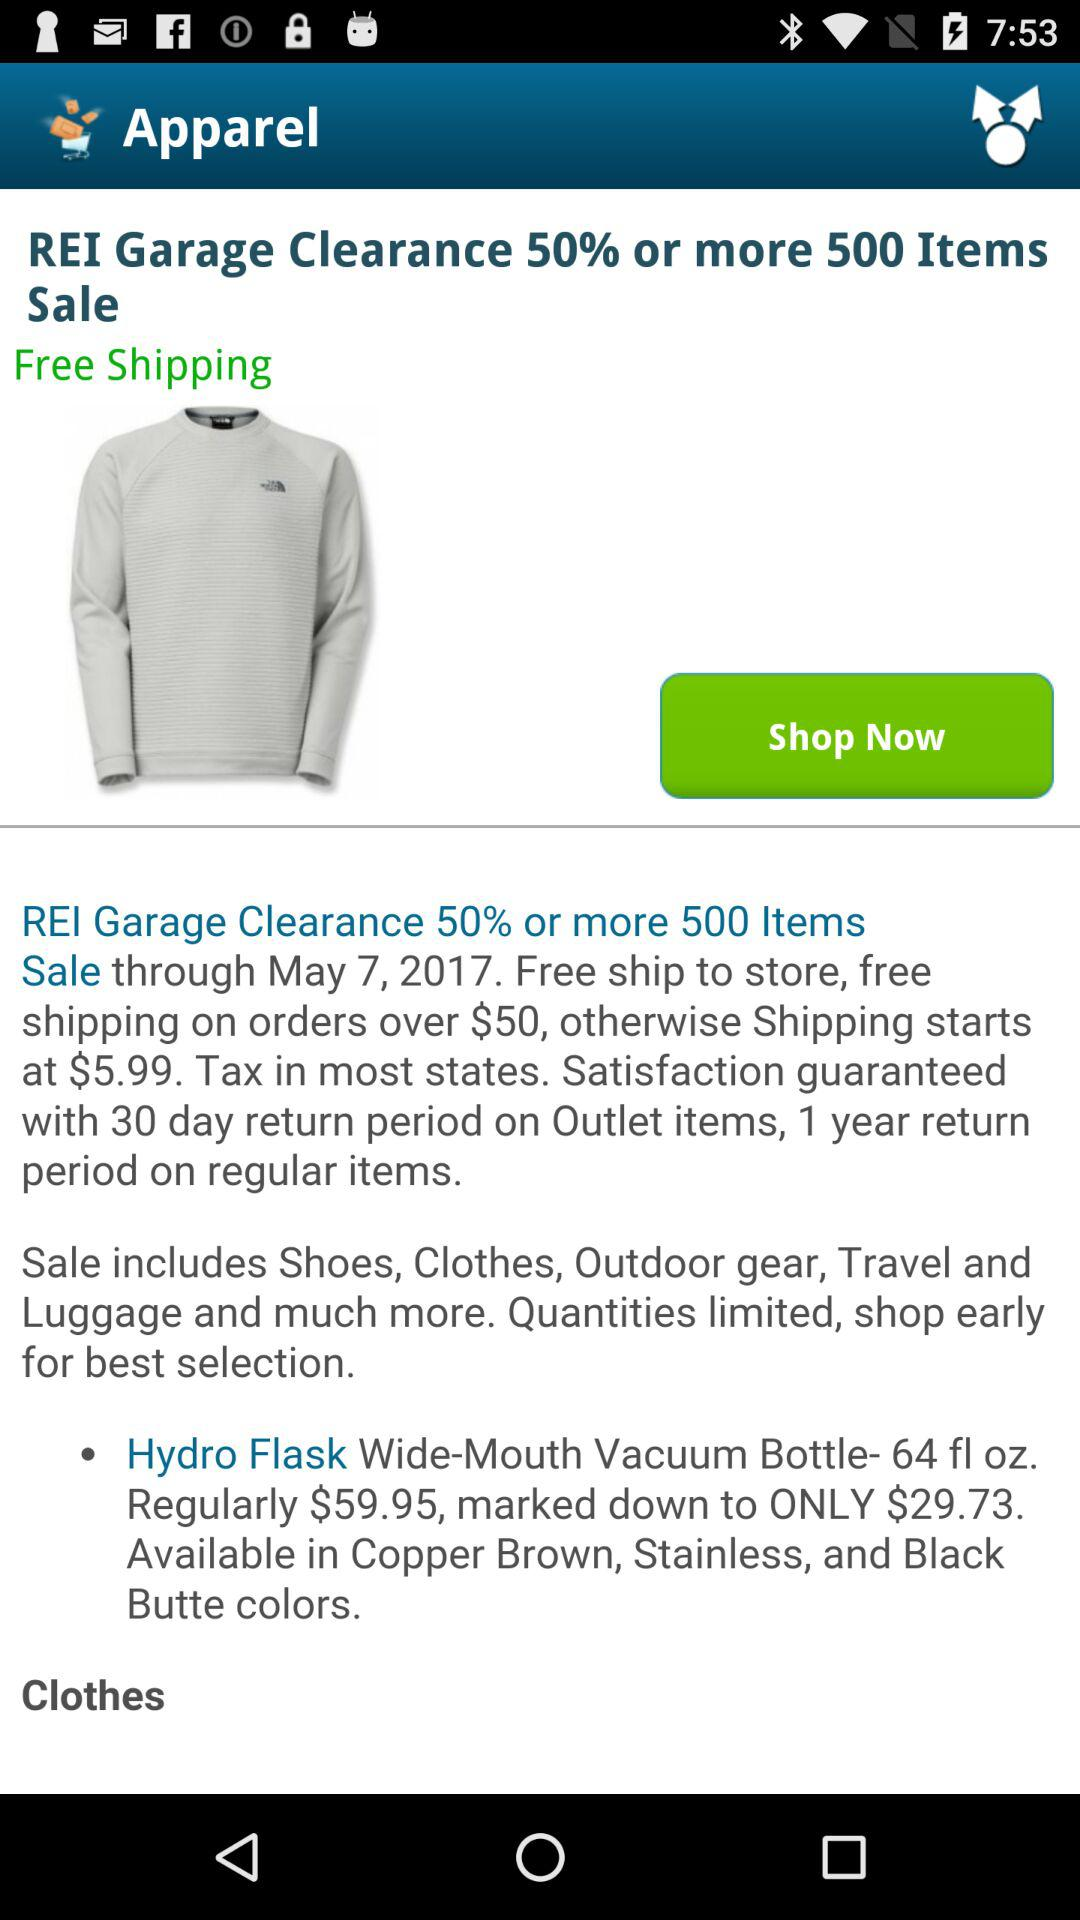What is the currency of the amount? The currency of the amount is $. 